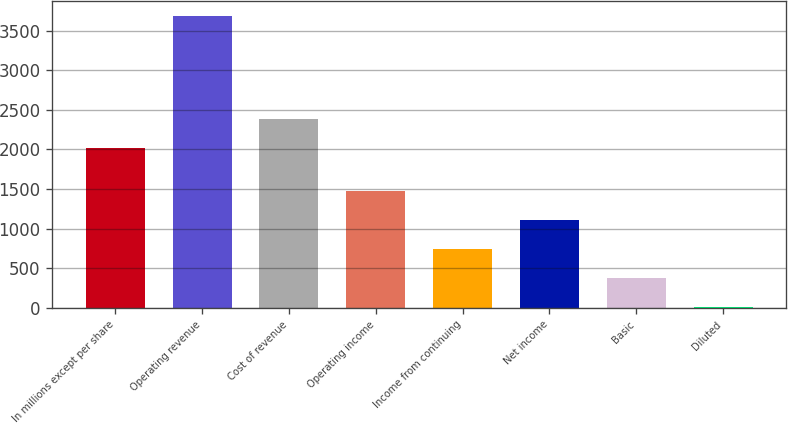<chart> <loc_0><loc_0><loc_500><loc_500><bar_chart><fcel>In millions except per share<fcel>Operating revenue<fcel>Cost of revenue<fcel>Operating income<fcel>Income from continuing<fcel>Net income<fcel>Basic<fcel>Diluted<nl><fcel>2014<fcel>3692<fcel>2383.07<fcel>1477.56<fcel>739.42<fcel>1108.49<fcel>370.35<fcel>1.28<nl></chart> 